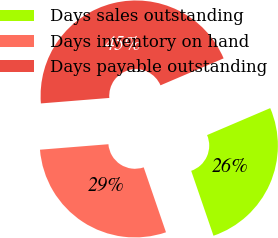<chart> <loc_0><loc_0><loc_500><loc_500><pie_chart><fcel>Days sales outstanding<fcel>Days inventory on hand<fcel>Days payable outstanding<nl><fcel>26.16%<fcel>28.99%<fcel>44.85%<nl></chart> 